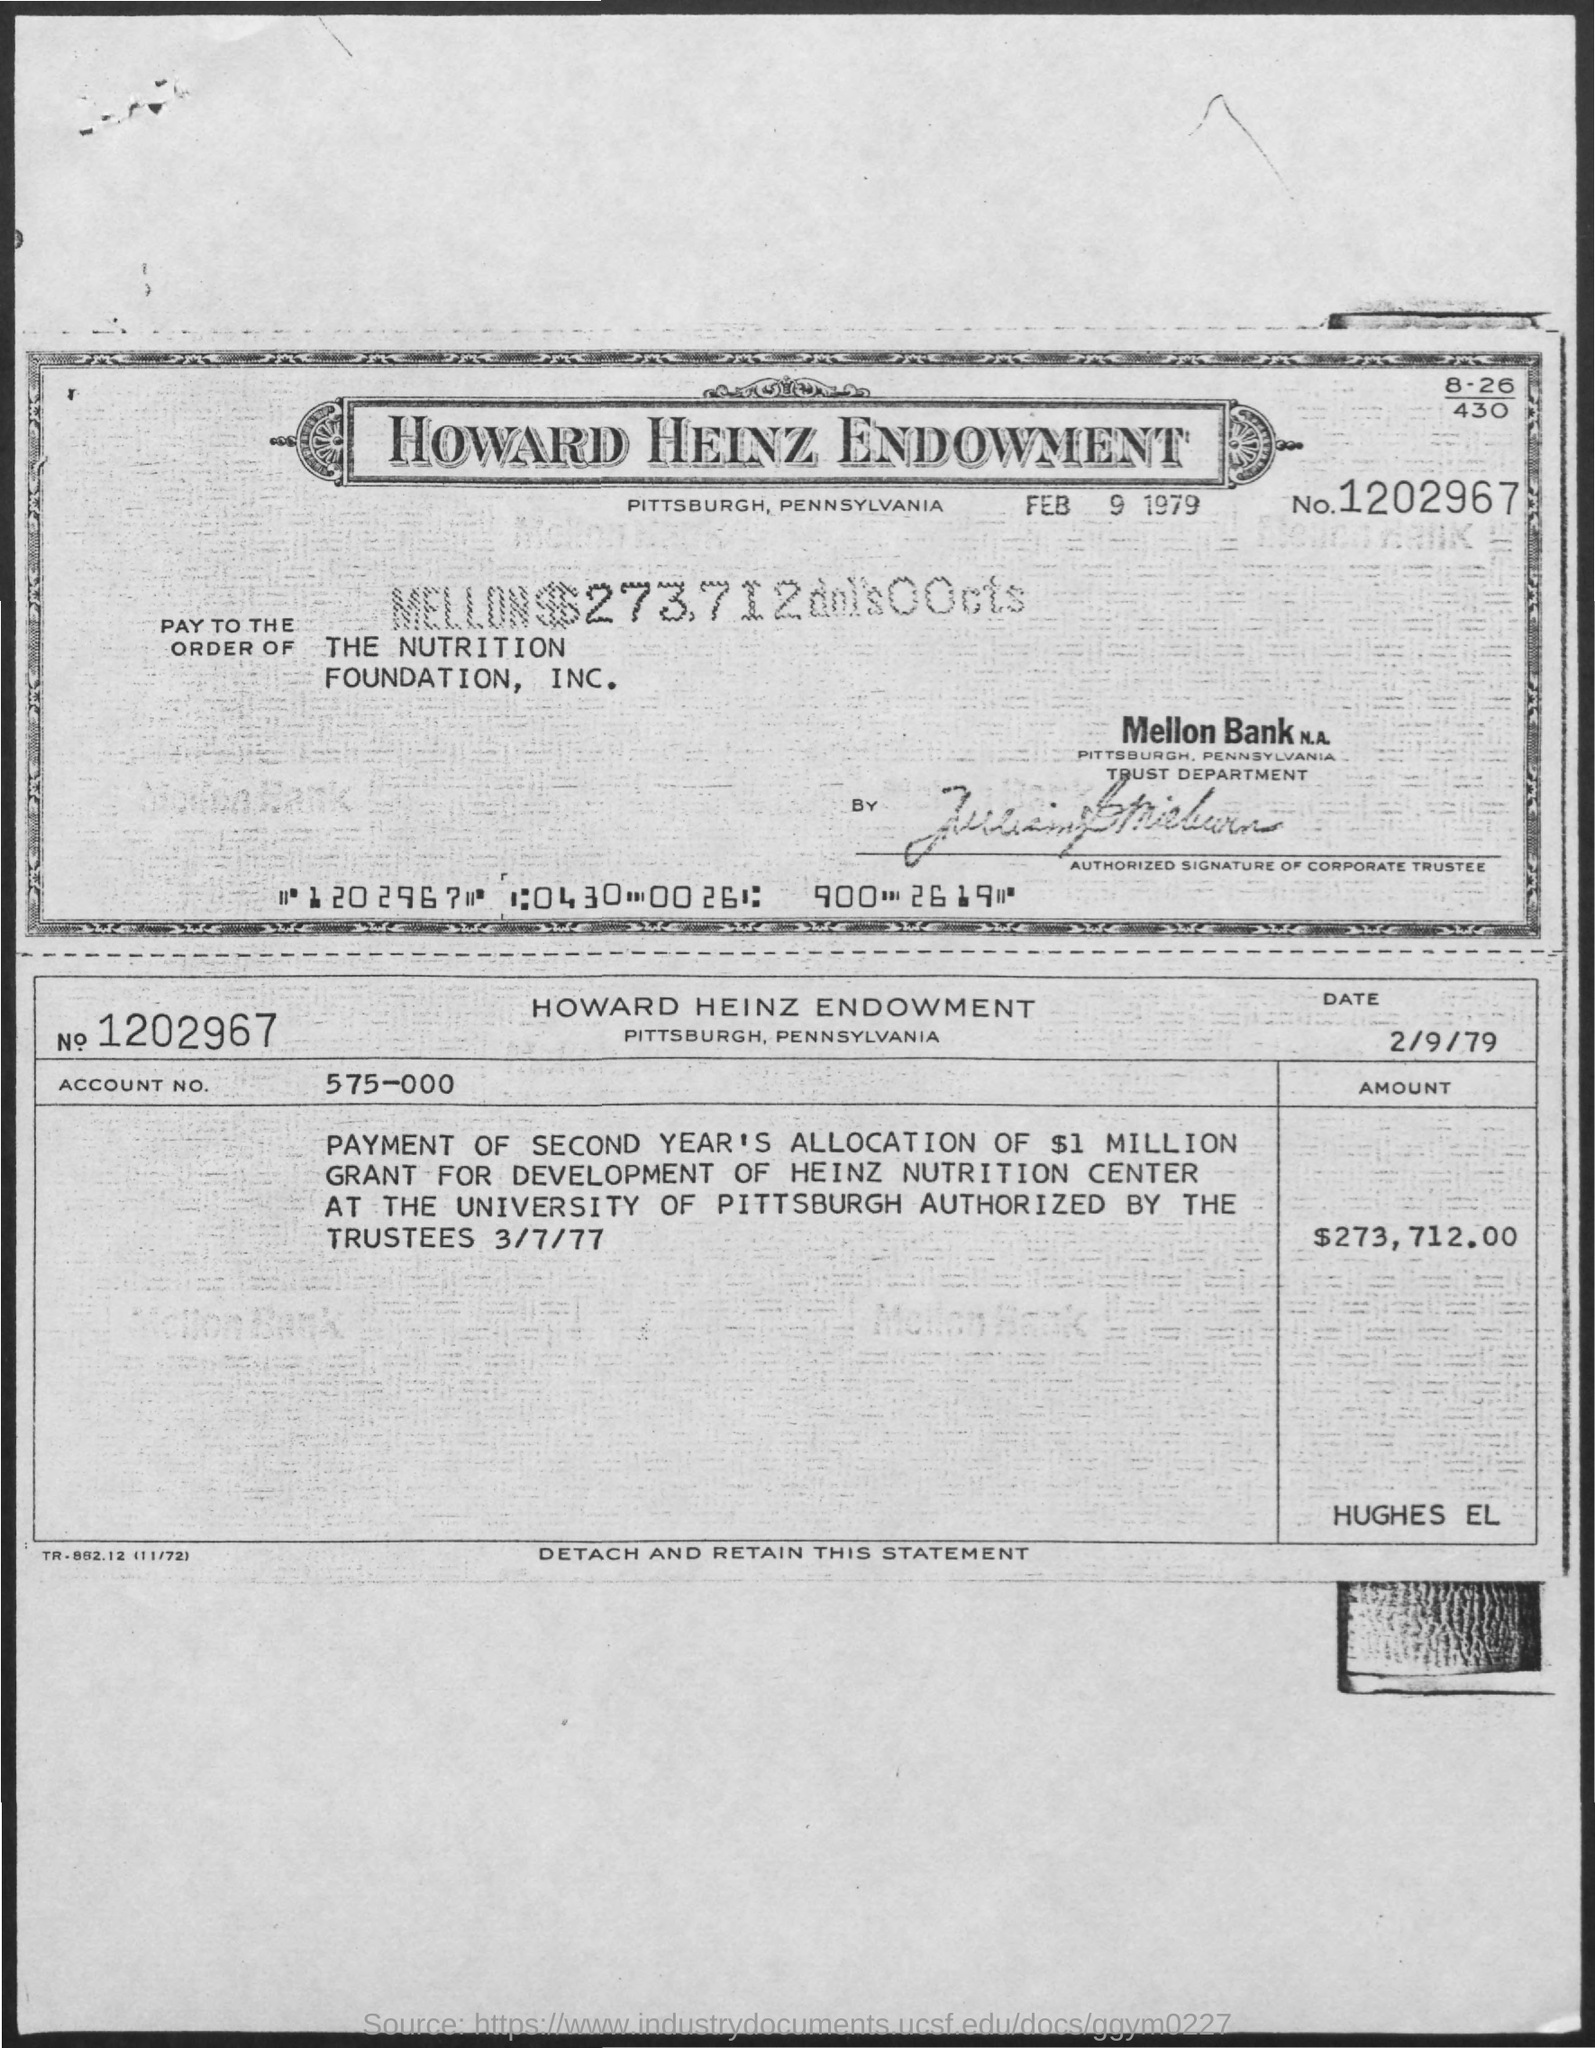Draw attention to some important aspects in this diagram. The name mentioned in the order of The Nutrition Foundation Inc. is [insert name]. The account number mentioned is 575-000... The date mentioned in the second copy is February 9, 1979. The date mentioned on the first copy is February 9, 1979. What is the number mentioned in the given form? It is 1202967... 